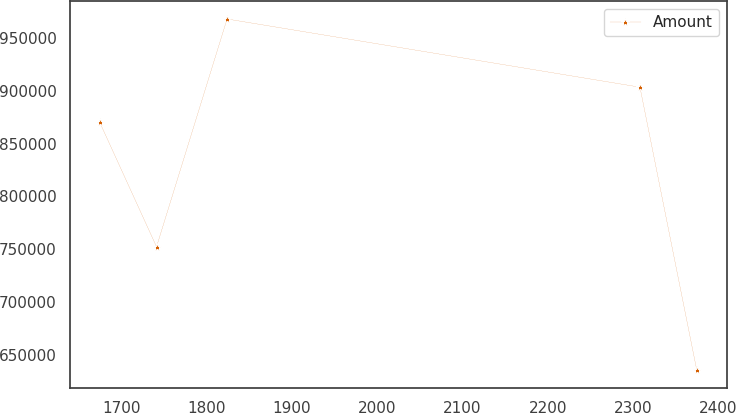Convert chart. <chart><loc_0><loc_0><loc_500><loc_500><line_chart><ecel><fcel>Amount<nl><fcel>1675<fcel>870153<nl><fcel>1741.56<fcel>752471<nl><fcel>1824.2<fcel>967830<nl><fcel>2307.91<fcel>903353<nl><fcel>2374.47<fcel>635829<nl></chart> 